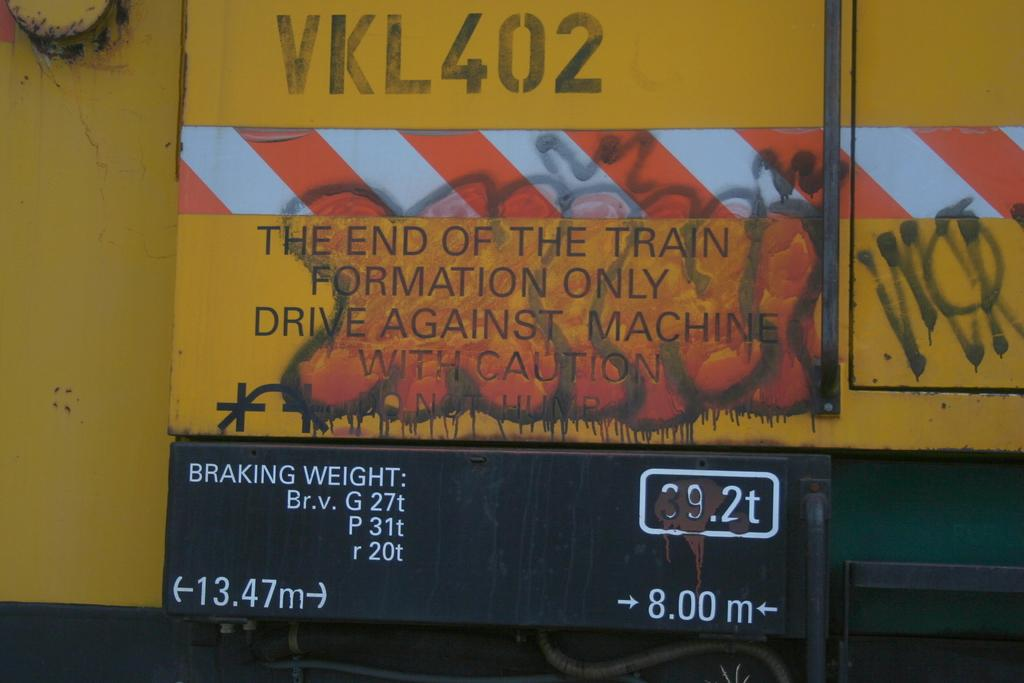<image>
Offer a succinct explanation of the picture presented. a yellow sign which states the end of the train formation only 